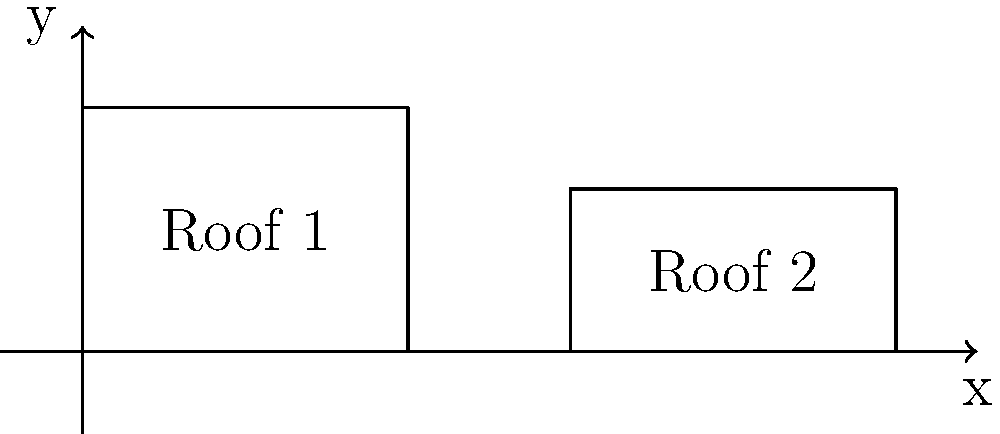Two solar panel arrays are installed on differently angled roofs as shown in the diagram. Roof 1 has dimensions 4 units by 3 units, while Roof 2 has dimensions 4 units by 2 units. If the solar panels on both roofs have the same efficiency and cover the entire roof area, which roof will generate more solar power, and by what percentage? To determine which roof will generate more solar power and by what percentage, we need to follow these steps:

1. Calculate the area of each roof:
   Roof 1 area: $A_1 = 4 \times 3 = 12$ square units
   Roof 2 area: $A_2 = 4 \times 2 = 8$ square units

2. Compare the areas:
   Roof 1 has a larger area, so it will generate more solar power.

3. Calculate the percentage difference:
   Percentage difference = $\frac{\text{Difference in area}}{\text{Smaller area}} \times 100\%$
   $= \frac{12 - 8}{8} \times 100\% = \frac{4}{8} \times 100\% = 50\%$

Therefore, Roof 1 will generate 50% more solar power than Roof 2.

It's important to note that in real-world scenarios, the angle of the roof also affects solar panel efficiency. However, for this problem, we assume equal efficiency on both roofs.
Answer: Roof 1, 50% more 